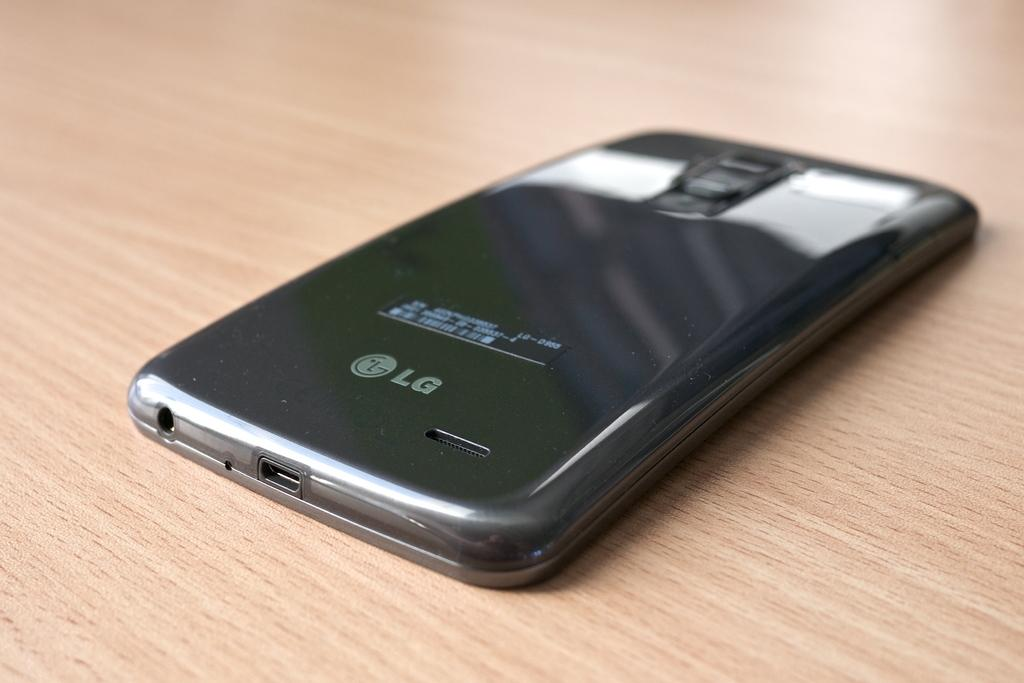<image>
Provide a brief description of the given image. A black LG phone is face down on a table. 